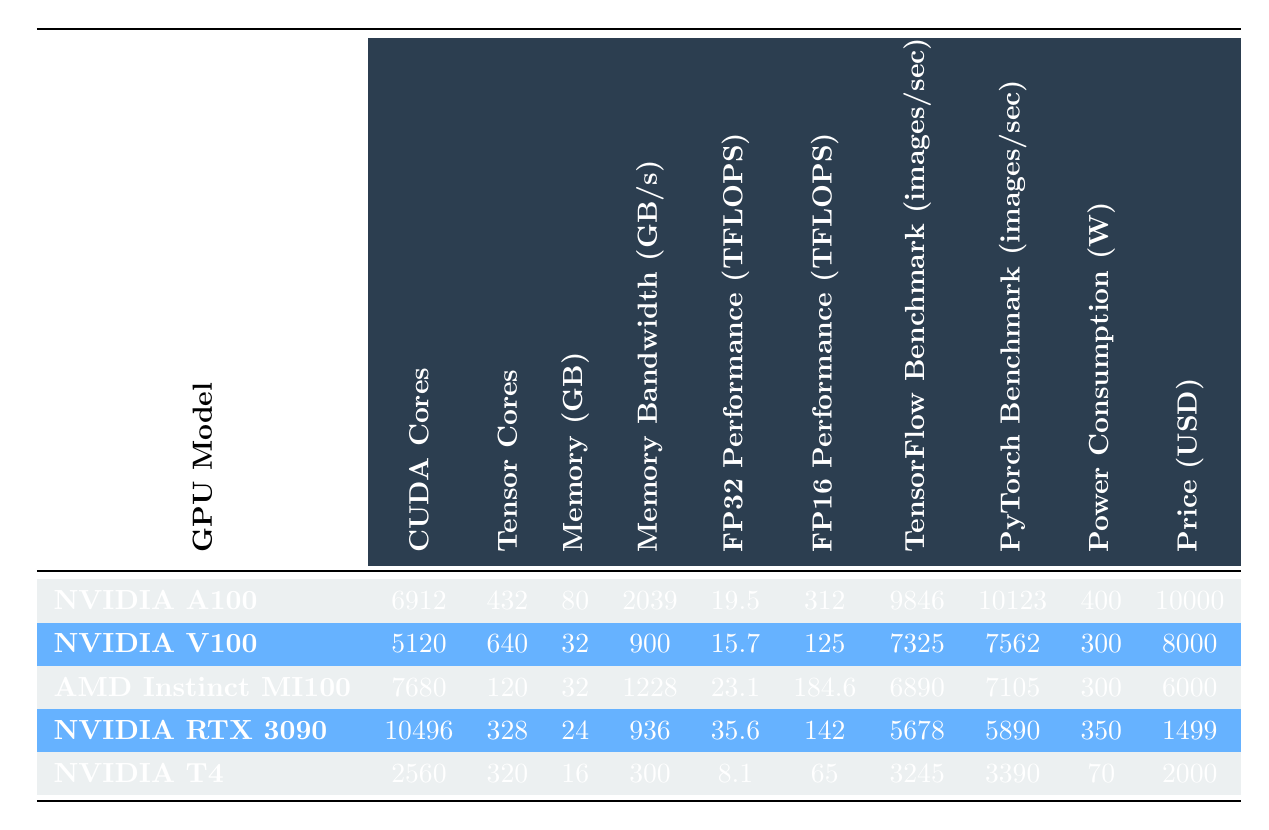What is the GPU model with the highest FP32 performance? The FP32 performance can be found in the "FP32 Performance (TFLOPS)" column. Looking through the values, the NVIDIA RTX 3090 has the highest FP32 performance of 35.6 TFLOPS.
Answer: NVIDIA RTX 3090 What is the memory size of the NVIDIA A100? The memory size is listed in the "Memory (GB)" column for each GPU. For the NVIDIA A100, the memory size is 80 GB.
Answer: 80 GB Which GPU has the lowest power consumption? The power consumption is found in the "Power Consumption (W)" column. Comparing the values, the NVIDIA T4 has the lowest power consumption at 70 W.
Answer: NVIDIA T4 What is the total FP16 performance of the NVIDIA V100 and the AMD Instinct MI100 combined? We add the FP16 performances of both GPUs: NVIDIA V100 is 125 TFLOPS, and AMD Instinct MI100 is 184.6 TFLOPS. Thus, total = 125 + 184.6 = 309.6 TFLOPS.
Answer: 309.6 TFLOPS Is the memory bandwidth of the AMD Instinct MI100 greater than 1000 GB/s? The memory bandwidth is listed as 1228 GB/s for the AMD Instinct MI100, which is greater than 1000. Thus, the answer is yes.
Answer: Yes Which GPU has the highest price, and what is that price? We look at the "Price (USD)" column to identify the highest price. The NVIDIA A100 is priced at 10000 USD, which is the highest.
Answer: NVIDIA A100, 10000 USD What is the average power consumption of the AMD Instinct MI100 and the NVIDIA V100? We calculate the average by adding the power consumption of both: AMD Instinct MI100 is 300 W, and NVIDIA V100 is also 300 W. Then the average = (300 + 300) / 2 = 300 W.
Answer: 300 W Which GPU model shows better PyTorch performance, NVIDIA A100 or NVIDIA V100? The PyTorch benchmarks are listed in the "PyTorch Benchmark (images/sec)" column. NVIDIA A100 shows 10123 images/sec, and NVIDIA V100 shows 7562 images/sec. Since 10123 > 7562, NVIDIA A100 shows better performance.
Answer: NVIDIA A100 Is the TensorFlow benchmark for the NVIDIA T4 lower than 4000 images/sec? According to the "TensorFlow Benchmark (images/sec)" column, the NVIDIA T4 has a benchmark of 3245 images/sec, which is indeed lower than 4000. Hence, the answer is yes.
Answer: Yes 